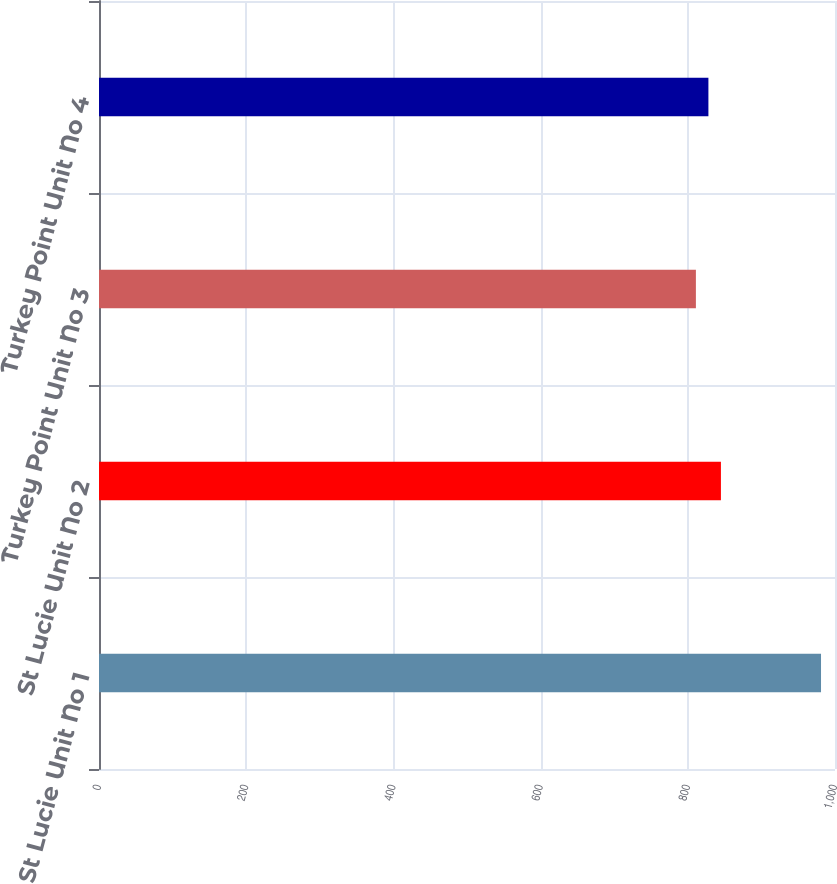Convert chart to OTSL. <chart><loc_0><loc_0><loc_500><loc_500><bar_chart><fcel>St Lucie Unit No 1<fcel>St Lucie Unit No 2<fcel>Turkey Point Unit No 3<fcel>Turkey Point Unit No 4<nl><fcel>981<fcel>845<fcel>811<fcel>828<nl></chart> 